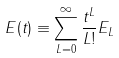<formula> <loc_0><loc_0><loc_500><loc_500>E ( t ) \equiv \sum _ { L = 0 } ^ { \infty } \frac { t ^ { L } } { L ! } E _ { L }</formula> 